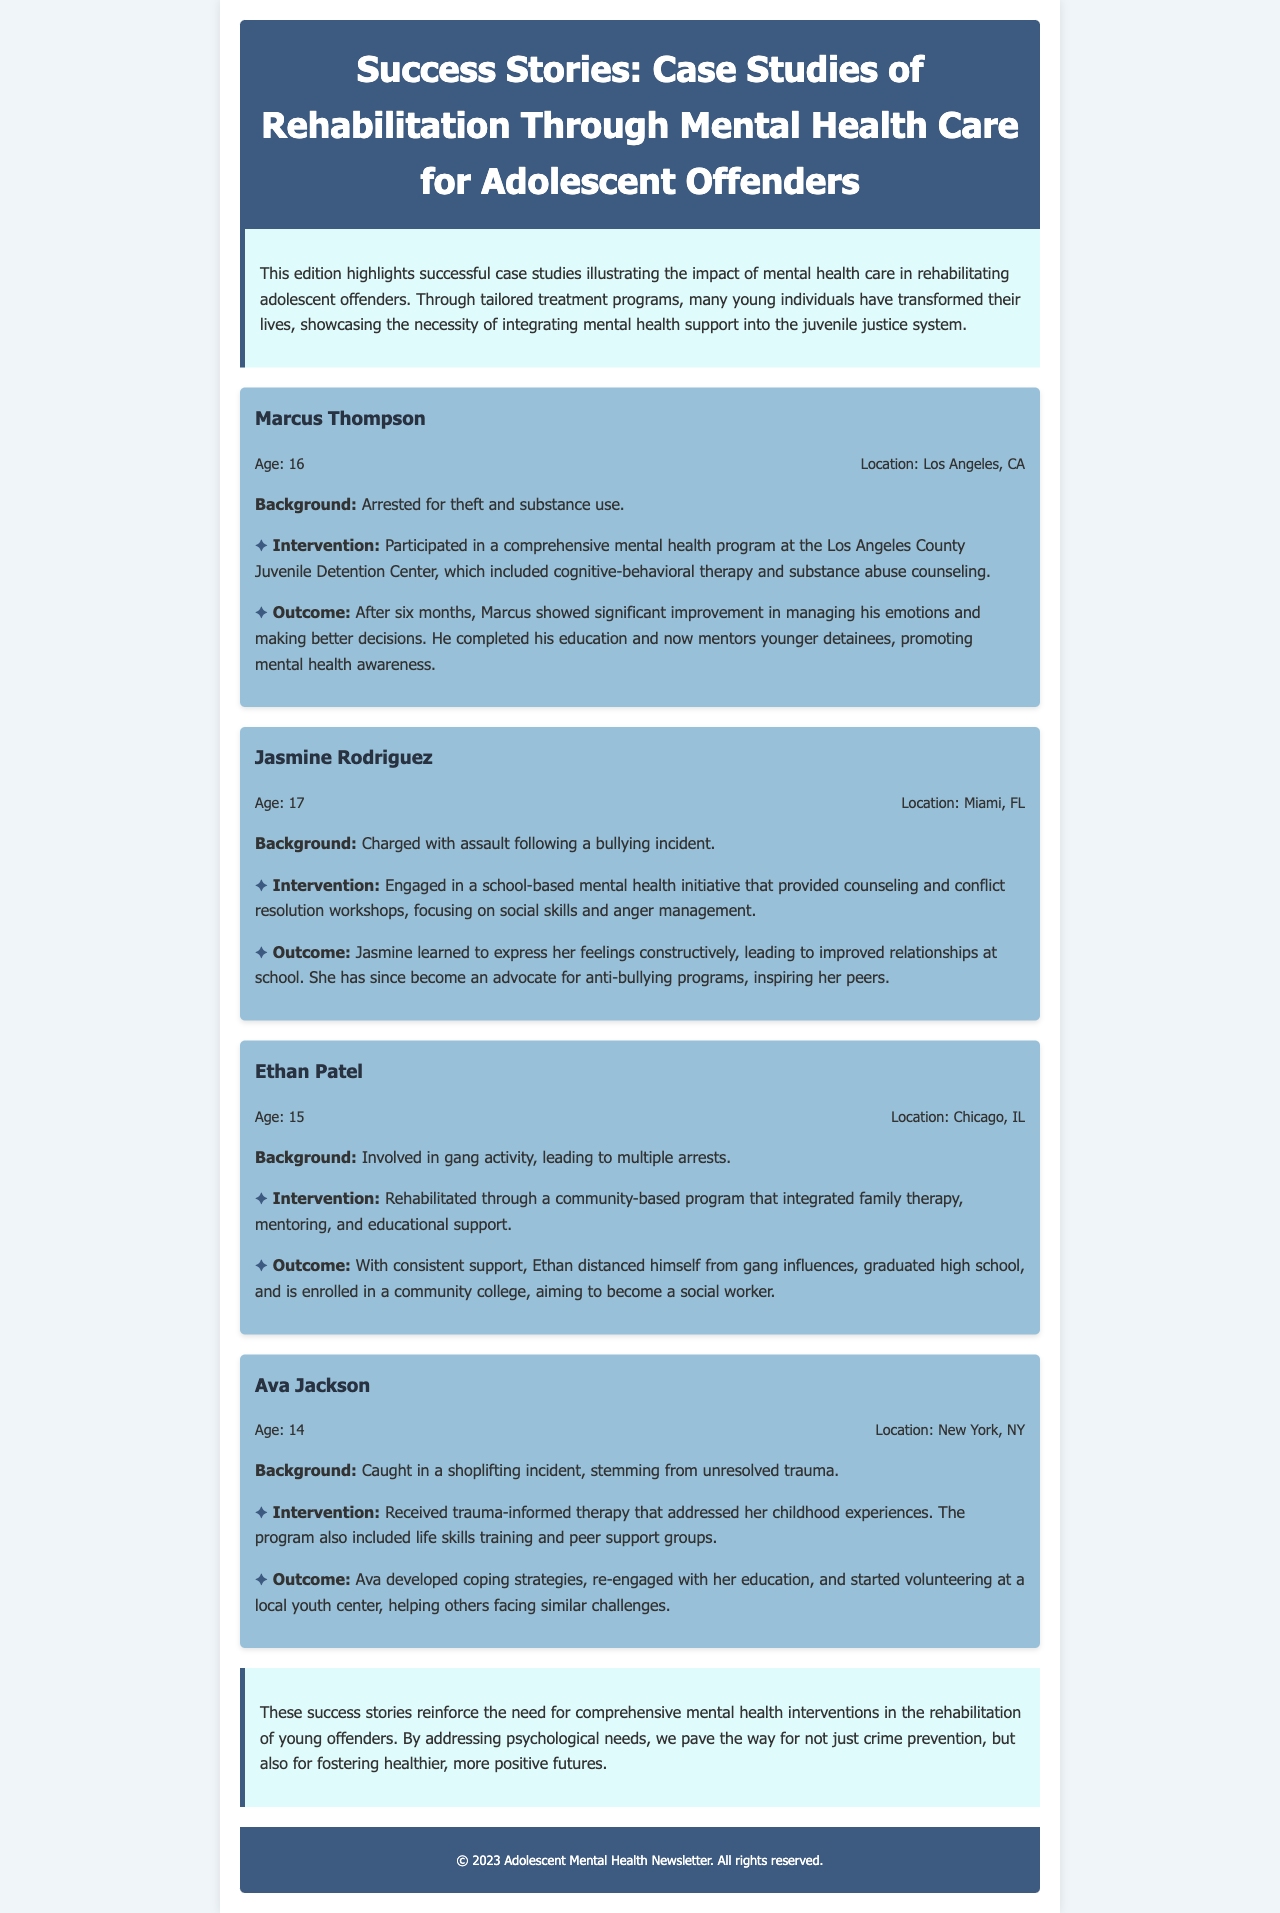What is the age of Marcus Thompson? Marcus Thompson is 16 years old, as mentioned in the case study section.
Answer: 16 What intervention did Jasmine Rodriguez participate in? Jasmine Rodriguez engaged in a school-based mental health initiative that included counseling and conflict resolution workshops.
Answer: School-based mental health initiative What is the location of Ethan Patel? Ethan Patel is from Chicago, IL, which is specified in his case study information.
Answer: Chicago, IL How long did Marcus Thompson participate in the rehabilitation program? Marcus Thompson participated in the program for six months, as stated in the outcome section of his case study.
Answer: Six months What is Ava Jackson's primary focus in her volunteer work? Ava Jackson helps others facing similar challenges, which is part of her volunteer work at a local youth center.
Answer: Helping others Which case study mentions family therapy as part of the intervention? The case study for Ethan Patel mentions that family therapy was part of his rehabilitation program.
Answer: Ethan Patel What was Jasmine Rodriguez's background incident? Jasmine Rodriguez was charged with assault following a bullying incident, outlined in her case study background.
Answer: Assault following a bullying incident What common theme does the newsletter highlight across the success stories? The common theme is the impact of mental health care in rehabilitating young individuals, emphasized in the introduction and conclusion.
Answer: Impact of mental health care What does the conclusion suggest about comprehensive mental health interventions? The conclusion suggests that comprehensive mental health interventions pave the way for crime prevention and healthier futures.
Answer: Crime prevention and healthier futures 